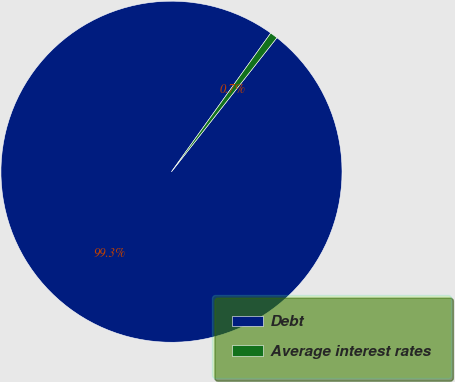Convert chart. <chart><loc_0><loc_0><loc_500><loc_500><pie_chart><fcel>Debt<fcel>Average interest rates<nl><fcel>99.28%<fcel>0.72%<nl></chart> 